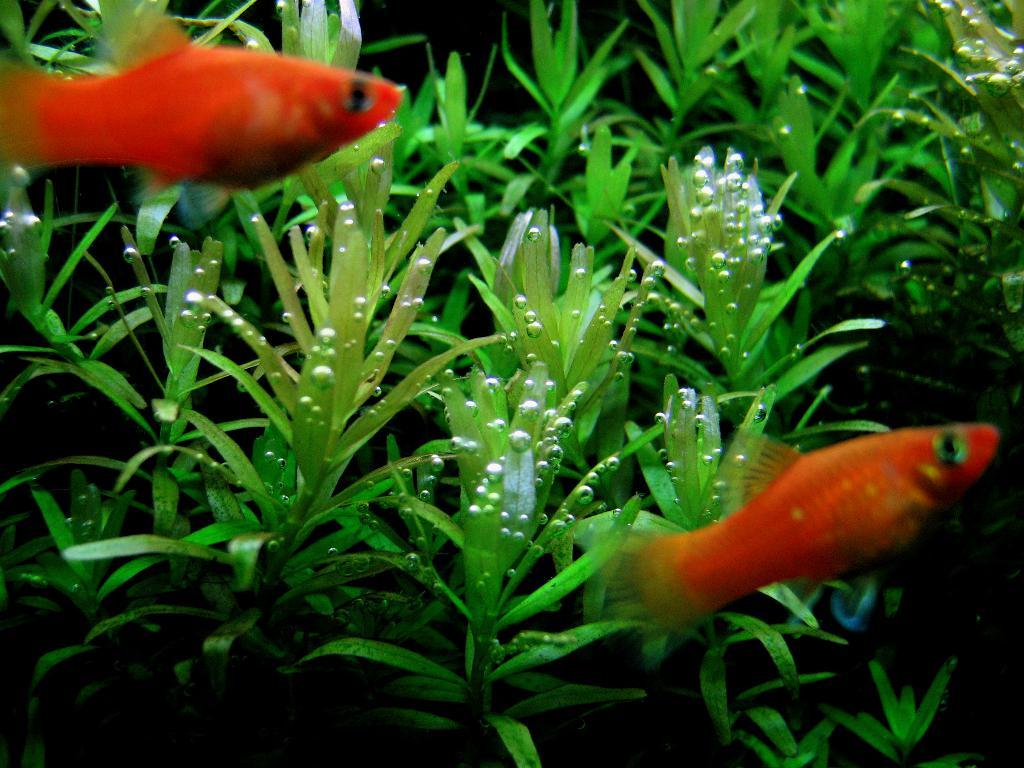What is happening in the water body in the image? There are fishes swimming in the water body. What else can be seen in the water body besides the fishes? Marine plants are present in the image. What other objects can be seen in the image besides the water body? There are other objects visible in the image. What type of beef is being served on the page in the image? There is no page or beef present in the image; it features a water body with fishes and marine plants. 